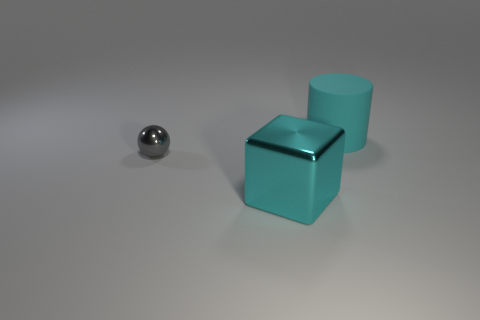What is the shape of the object that is behind the shiny thing that is behind the cyan object that is in front of the big cylinder?
Offer a terse response. Cylinder. What is the shape of the cyan metal thing?
Your response must be concise. Cube. What is the color of the object left of the block?
Offer a very short reply. Gray. There is a cyan thing left of the rubber cylinder; does it have the same size as the large rubber object?
Your answer should be compact. Yes. Is there anything else that is the same size as the gray thing?
Keep it short and to the point. No. Are there fewer big metal blocks that are behind the tiny metallic sphere than gray metal balls that are in front of the cyan rubber thing?
Your response must be concise. Yes. What number of shiny cubes are on the left side of the big cyan cylinder?
Provide a succinct answer. 1. There is a large thing that is in front of the small metal sphere; is its shape the same as the object behind the ball?
Give a very brief answer. No. How many other objects are the same color as the big metallic cube?
Offer a terse response. 1. What is the material of the thing to the right of the metallic thing right of the gray metal object that is in front of the matte cylinder?
Provide a succinct answer. Rubber. 